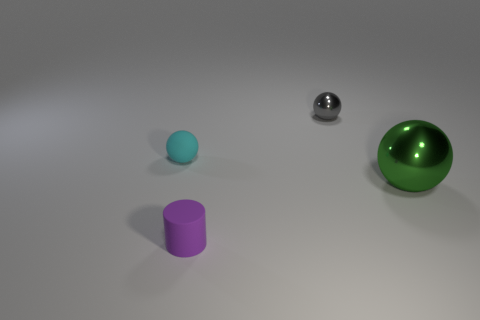Do the tiny gray sphere behind the big sphere and the tiny object in front of the large green metal ball have the same material?
Ensure brevity in your answer.  No. There is another big object that is the same shape as the cyan rubber object; what is it made of?
Provide a succinct answer. Metal. Is the material of the large thing the same as the gray object?
Make the answer very short. Yes. There is a matte object that is right of the small matte object behind the large green sphere; what color is it?
Your answer should be compact. Purple. There is a cyan ball that is the same material as the purple cylinder; what size is it?
Provide a short and direct response. Small. How many other tiny metal objects are the same shape as the green metal object?
Make the answer very short. 1. What number of objects are either spheres on the left side of the large metallic object or spheres that are on the right side of the small purple matte cylinder?
Provide a short and direct response. 3. What number of tiny matte objects are right of the small ball that is in front of the gray metallic sphere?
Make the answer very short. 1. There is a metallic thing that is in front of the tiny gray metallic ball; is its shape the same as the rubber object that is behind the small purple rubber cylinder?
Keep it short and to the point. Yes. Are there any big purple cylinders that have the same material as the small cyan sphere?
Ensure brevity in your answer.  No. 